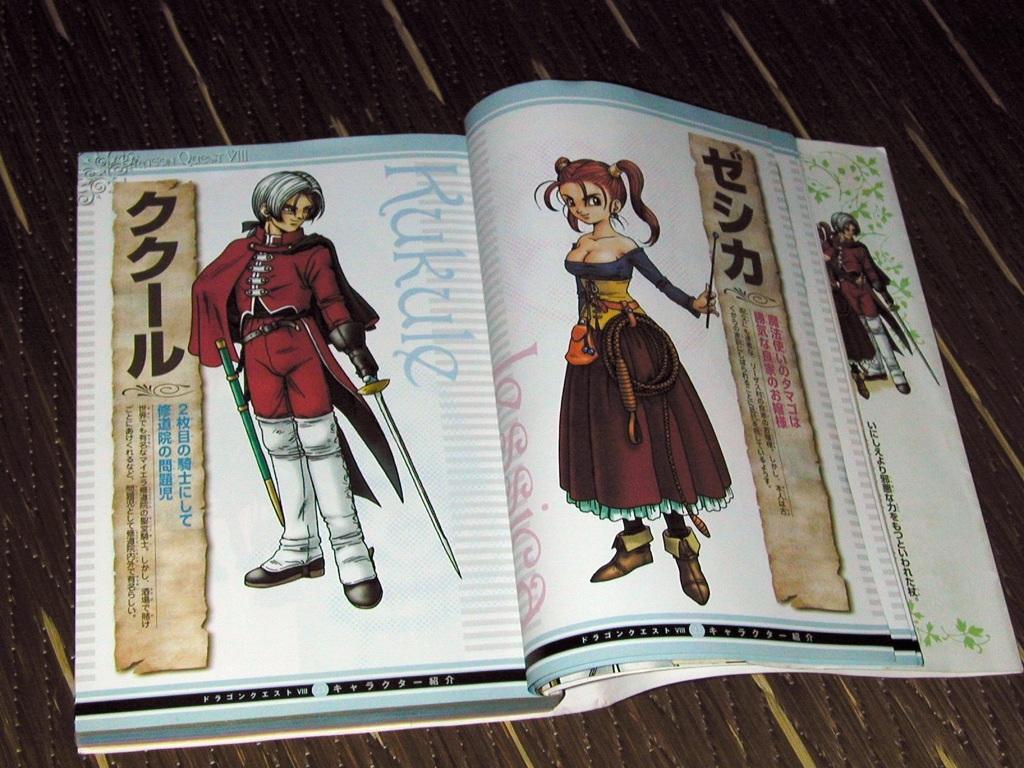What is the girl's name?
Ensure brevity in your answer.  Jessica. 